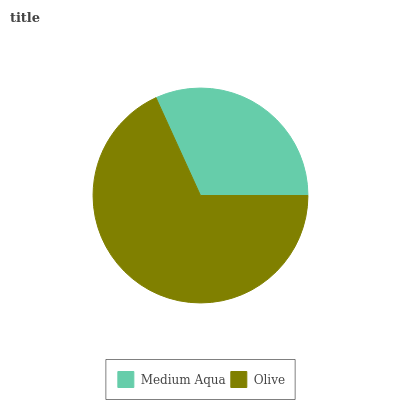Is Medium Aqua the minimum?
Answer yes or no. Yes. Is Olive the maximum?
Answer yes or no. Yes. Is Olive the minimum?
Answer yes or no. No. Is Olive greater than Medium Aqua?
Answer yes or no. Yes. Is Medium Aqua less than Olive?
Answer yes or no. Yes. Is Medium Aqua greater than Olive?
Answer yes or no. No. Is Olive less than Medium Aqua?
Answer yes or no. No. Is Olive the high median?
Answer yes or no. Yes. Is Medium Aqua the low median?
Answer yes or no. Yes. Is Medium Aqua the high median?
Answer yes or no. No. Is Olive the low median?
Answer yes or no. No. 